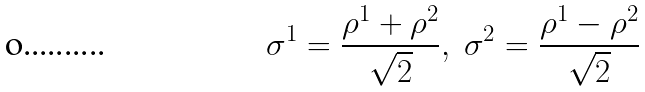Convert formula to latex. <formula><loc_0><loc_0><loc_500><loc_500>\sigma ^ { 1 } = \frac { \rho ^ { 1 } + \rho ^ { 2 } } { \sqrt { 2 } } , \ \sigma ^ { 2 } = \frac { \rho ^ { 1 } - \rho ^ { 2 } } { \sqrt { 2 } }</formula> 